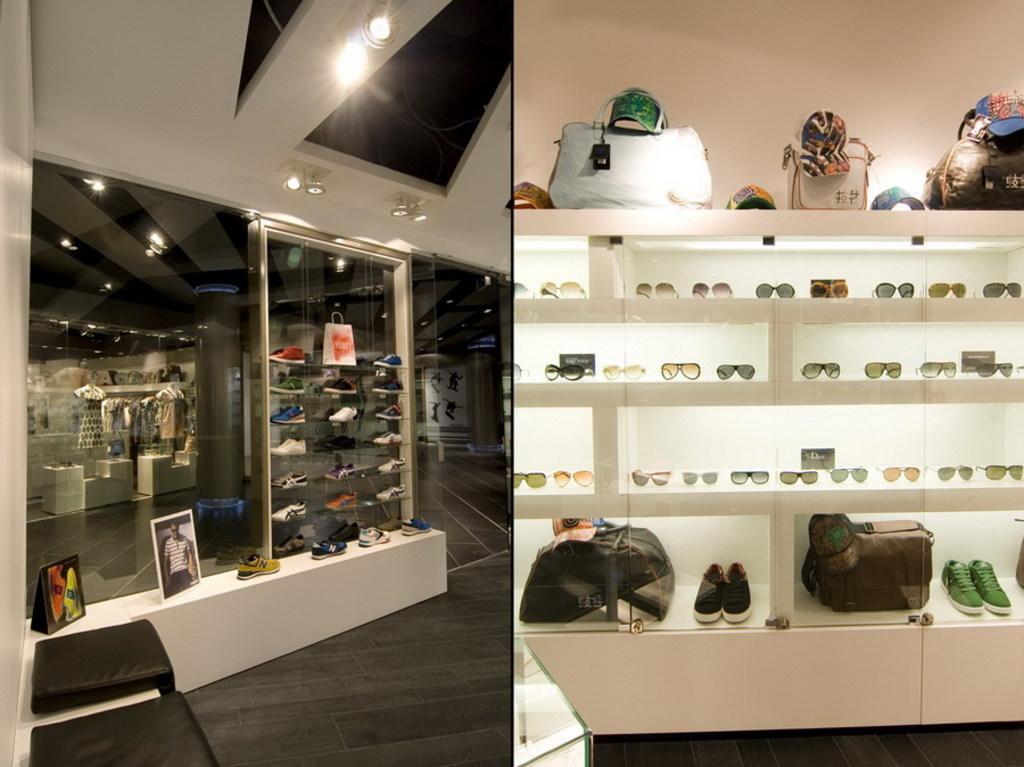Could you give a brief overview of what you see in this image? In this picture we can see a mirror, and couple of bags, shoes, spectacles are in the racks. 